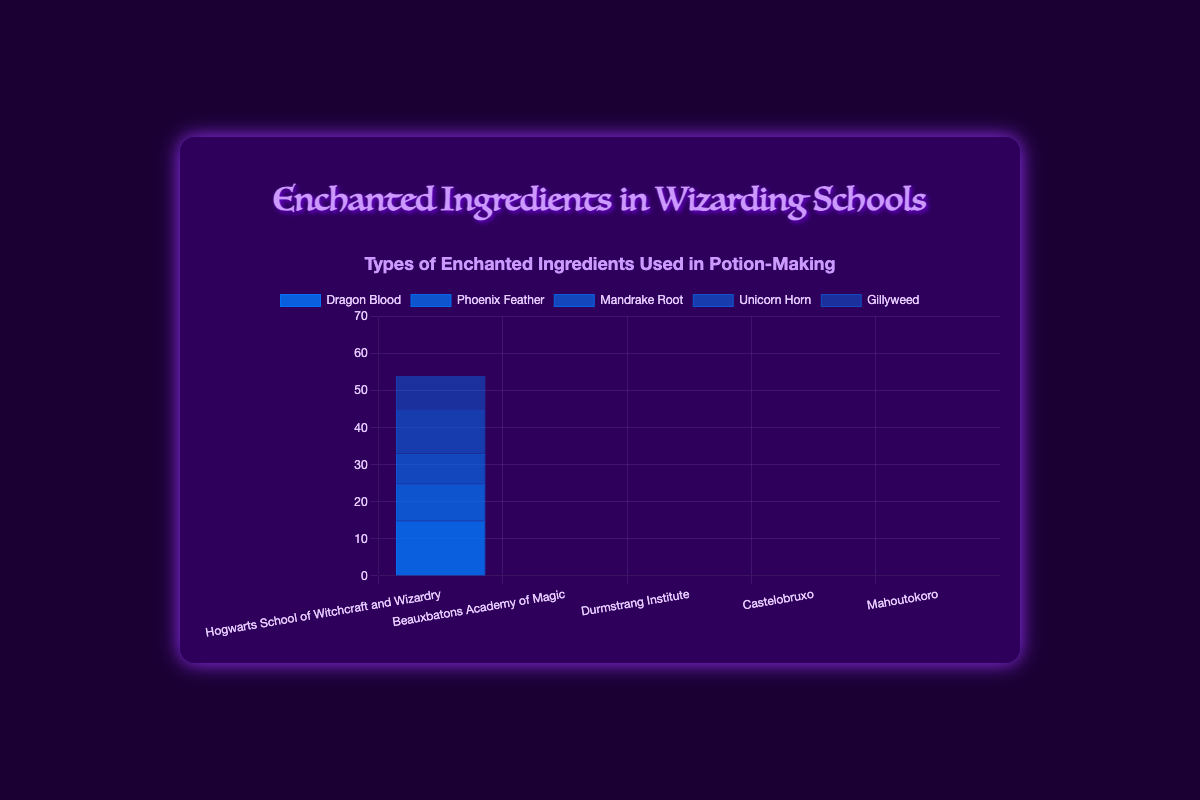Which school uses the most Phoenix Feather in potion-making? To find the answer, look at the bar representing Phoenix Feather usage in each school. The tallest bar indicates the highest use. Hogwarts School of Witchcraft and Wizardry shows the highest bar for Phoenix Feather.
Answer: Hogwarts School of Witchcraft and Wizardry Which ingredient has the highest usage in Durmstrang Institute? Look at the bars representing different ingredients for Durmstrang Institute and identify the tallest one. Ghoul Nails has the highest bar among the ingredients.
Answer: Ghoul Nails Between Beauxbatons Academy of Magic and Castelobruxo, which school uses more Bicorn Horn? Compare the heights of the bars labeled Bicorn Horn for both Beauxbatons Academy of Magic and Castelobruxo. Beauxbatons Academy of Magic has a bar, but Castelobruxo does not use Bicorn Horn at all.
Answer: Beauxbatons Academy of Magic What's the total usage of Unicorn Horn in all schools combined? Add up the values of Unicorn Horn usage for each school. Only Hogwarts School of Witchcraft and Wizardry uses Unicorn Horn with a count of 12.
Answer: 12 Which ingredient is least used by any single school? Examine the lowest bar in each category for each school. The smallest bar is for Moondew in Beauxbatons Academy of Magic, which is used 7 times.
Answer: Moondew (in Beauxbatons Academy of Magic) What’s the difference in usage of Kirin Bone between Mahoutokoro and Hogwarts School of Witchcraft and Wizardry? Look at the bars for Kirin Bone for both schools and subtract their values. Mahoutokoro has a Kirin Bone usage of 11, whereas Hogwarts does not use it at all (0). The difference is 11 - 0.
Answer: 11 If we calculate the average number of times all ingredients are used in Hogwarts School of Witchcraft and Wizardry, what would it be? Sum the ingredient counts for Hogwarts (15 + 10 + 8 + 12 + 9 = 54) and divide by the number of different ingredients (5). The average is 54 / 5.
Answer: 10.8 